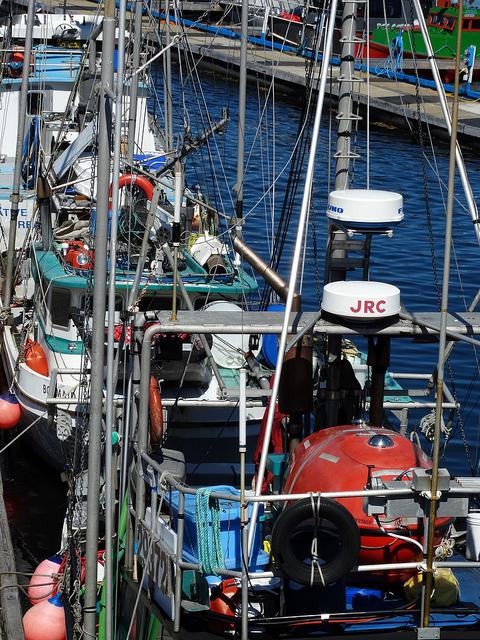What color are the round buoys on the left sides of these boats parked at the marina? red 